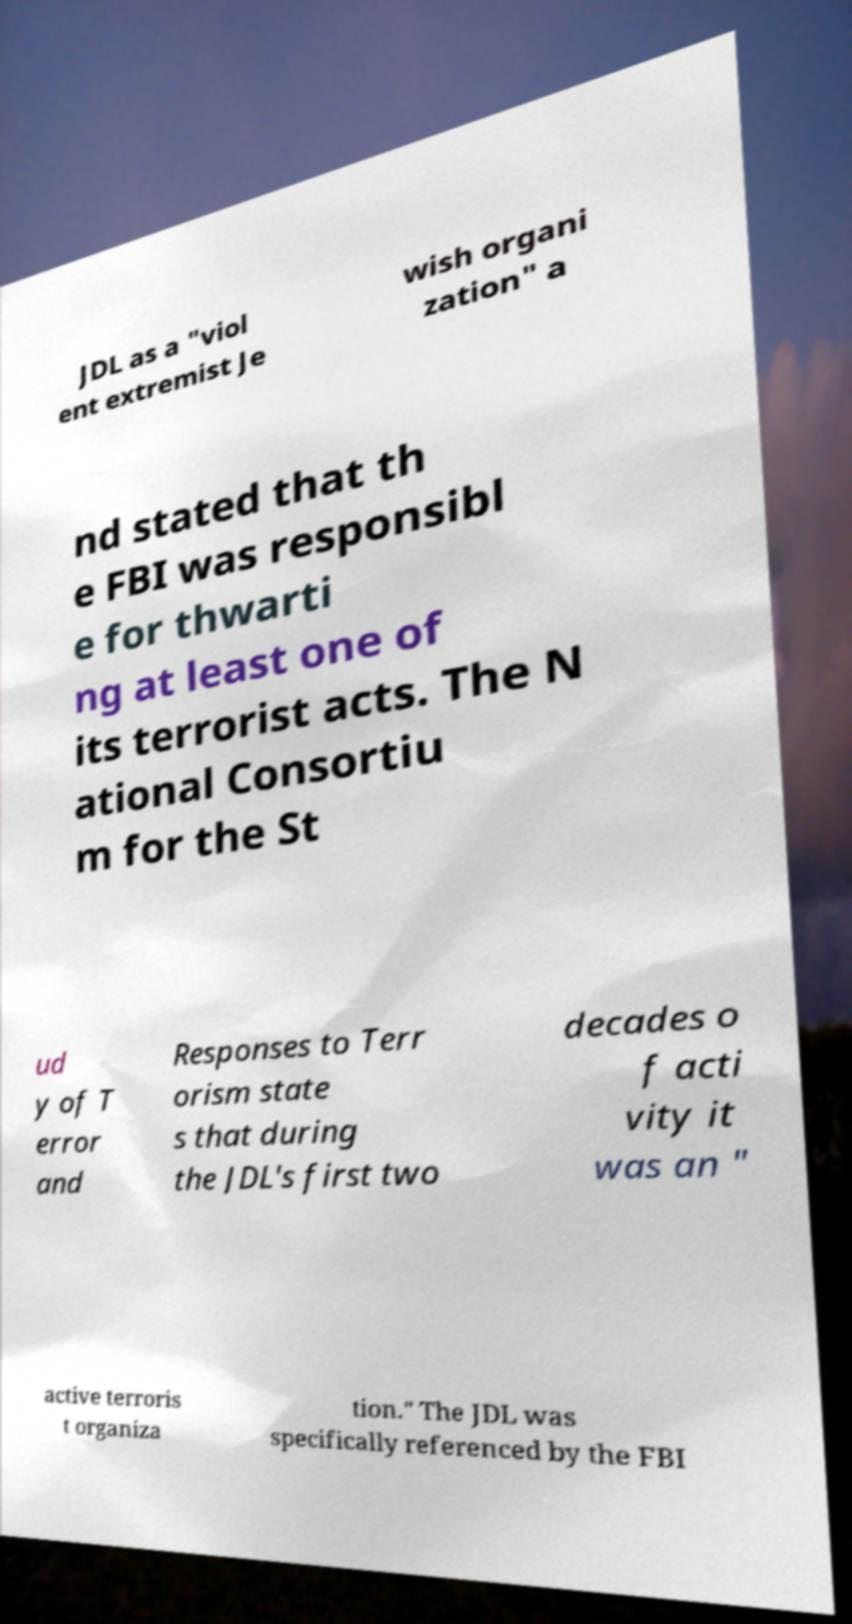Could you assist in decoding the text presented in this image and type it out clearly? JDL as a "viol ent extremist Je wish organi zation" a nd stated that th e FBI was responsibl e for thwarti ng at least one of its terrorist acts. The N ational Consortiu m for the St ud y of T error and Responses to Terr orism state s that during the JDL's first two decades o f acti vity it was an " active terroris t organiza tion." The JDL was specifically referenced by the FBI 